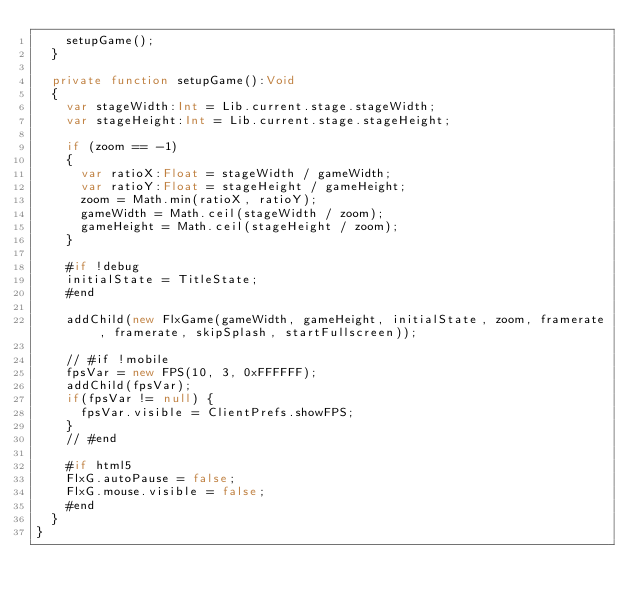Convert code to text. <code><loc_0><loc_0><loc_500><loc_500><_Haxe_>		setupGame();
	}

	private function setupGame():Void
	{
		var stageWidth:Int = Lib.current.stage.stageWidth;
		var stageHeight:Int = Lib.current.stage.stageHeight;

		if (zoom == -1)
		{
			var ratioX:Float = stageWidth / gameWidth;
			var ratioY:Float = stageHeight / gameHeight;
			zoom = Math.min(ratioX, ratioY);
			gameWidth = Math.ceil(stageWidth / zoom);
			gameHeight = Math.ceil(stageHeight / zoom);
		}

		#if !debug
		initialState = TitleState;
		#end

		addChild(new FlxGame(gameWidth, gameHeight, initialState, zoom, framerate, framerate, skipSplash, startFullscreen));

		// #if !mobile
		fpsVar = new FPS(10, 3, 0xFFFFFF);
		addChild(fpsVar);
		if(fpsVar != null) {
			fpsVar.visible = ClientPrefs.showFPS;
		}
		// #end

		#if html5
		FlxG.autoPause = false;
		FlxG.mouse.visible = false;
		#end
	}
}
</code> 